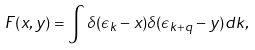Convert formula to latex. <formula><loc_0><loc_0><loc_500><loc_500>F ( x , y ) = \int \delta ( { \epsilon _ { k } } - x ) \delta ( { \epsilon _ { k + q } } - y ) d k ,</formula> 